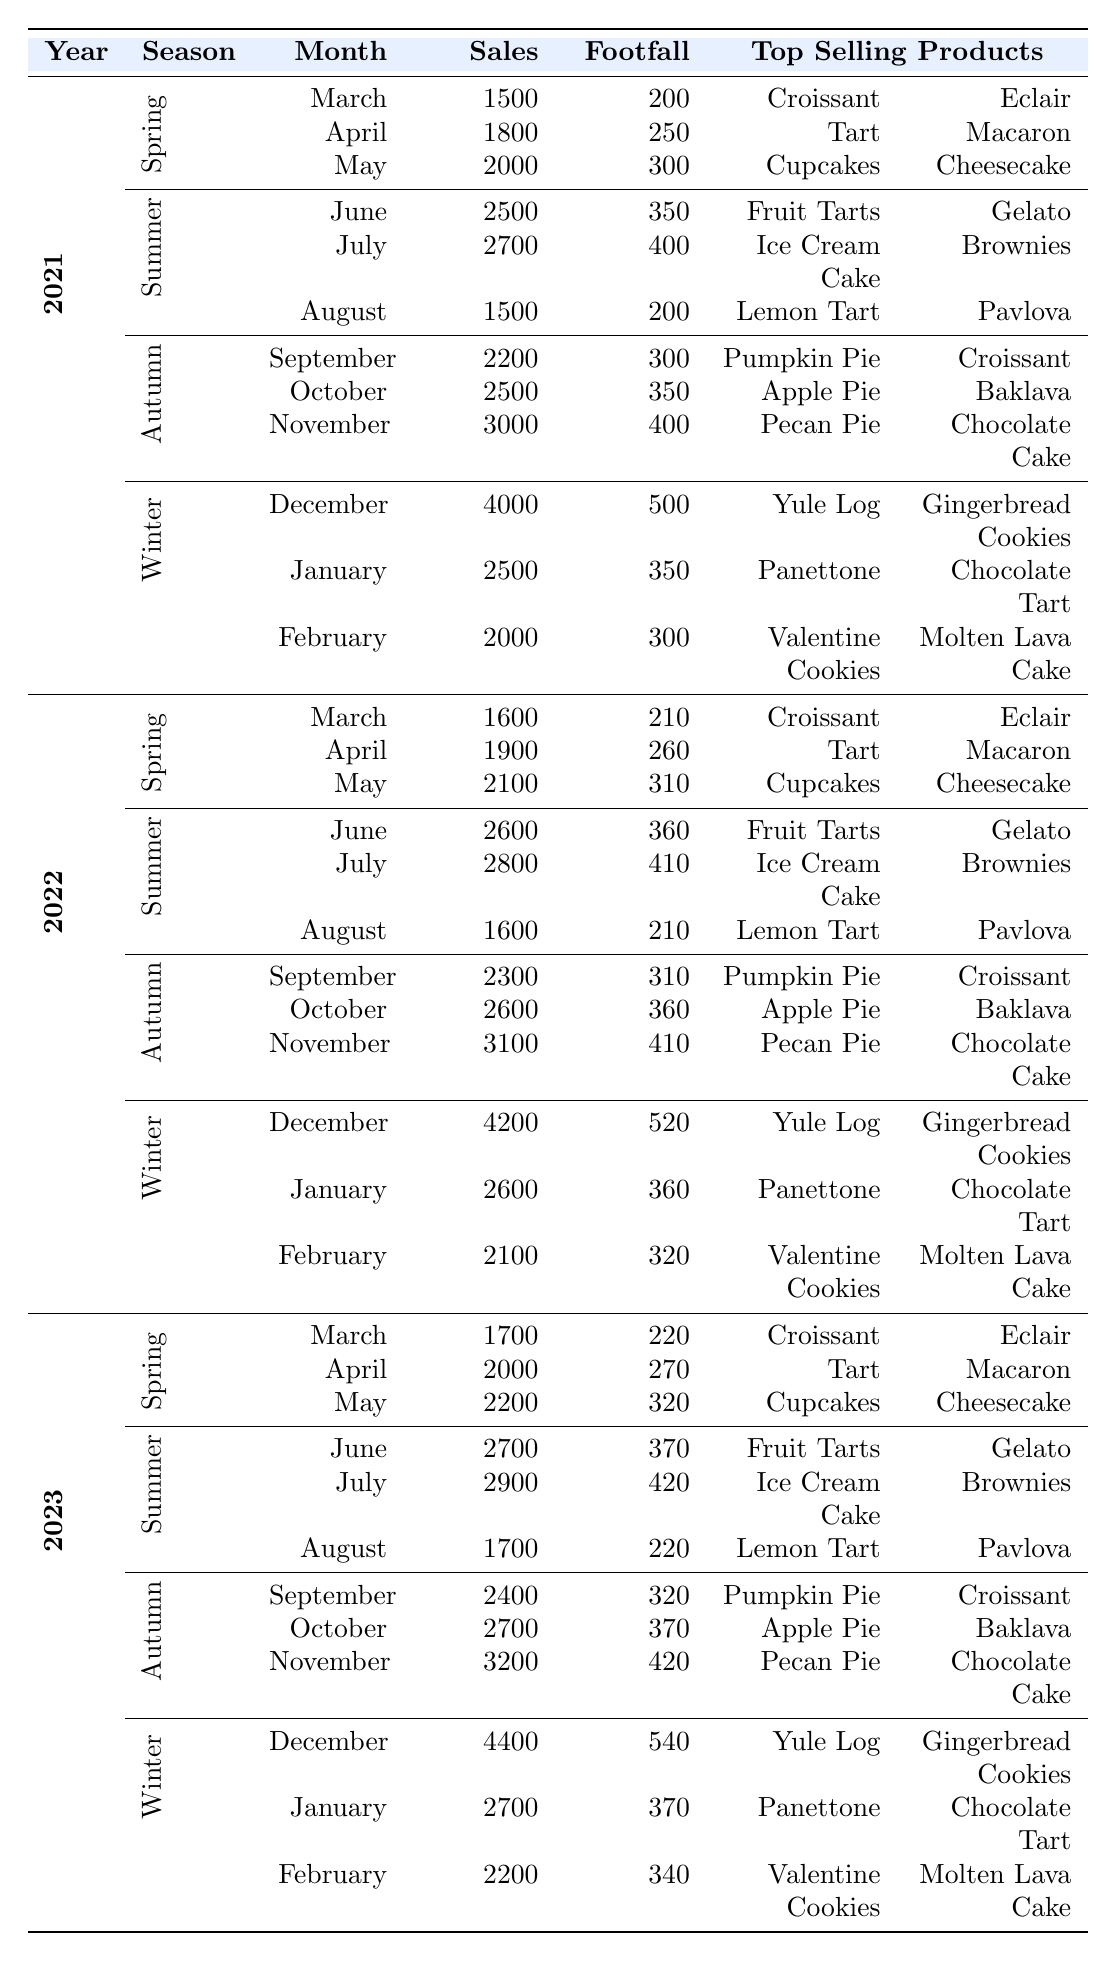What was the total sales for Winter in 2022? The total sales for Winter in 2022 include December (4200), January (2600), and February (2100). Adding them together gives 4200 + 2600 + 2100 = 8900.
Answer: 8900 Which month had the highest sales in 2021? In 2021, the month with the highest sales was December, with sales of 4000.
Answer: December Did more customers visit the bakery in October 2023 or October 2022? In October 2023, the customer footfall was 370, while in October 2022, it was 360. Therefore, more customers visited in October 2023.
Answer: Yes What is the average sales figure for Summer across the three years? The Summer sales figures are: 2021 (2500 + 2700 + 1500), 2022 (2600 + 2800 + 1600), and 2023 (2700 + 2900 + 1700). First, calculate the total sales for each year: 2021 = 6700, 2022 = 7000, 2023 = 7300. Then, sum these total sales: 6700 + 7000 + 7300 = 21000. To find the average, divide 21000 by 3: 21000 / 3 = 7000.
Answer: 7000 In which year did the bakery see a decrease in customer footfall during Spring? By checking the customer footfall in Spring (March, April, May) for 2021 (200, 250, 300), 2022 (210, 260, 310), and 2023 (220, 270, 320), we observe that there was no decrease in any year; all months increased in footfall compared to the previous year. Therefore, no year showed a decrease.
Answer: No year What is the difference in sales between the highest and lowest month in Autumn for 2021? In Autumn 2021, the sales were: September (2200), October (2500), and November (3000). The highest was November (3000) and the lowest was September (2200). The difference is calculated as 3000 - 2200 = 800.
Answer: 800 Which Top Selling Product was consistently reported in Spring across three years? By looking at the Top Selling Products in Spring for each year, Croissant and Eclair were the Top Selling Products for March in 2021, 2022, and 2023. Therefore, they were consistent.
Answer: Croissant and Eclair 